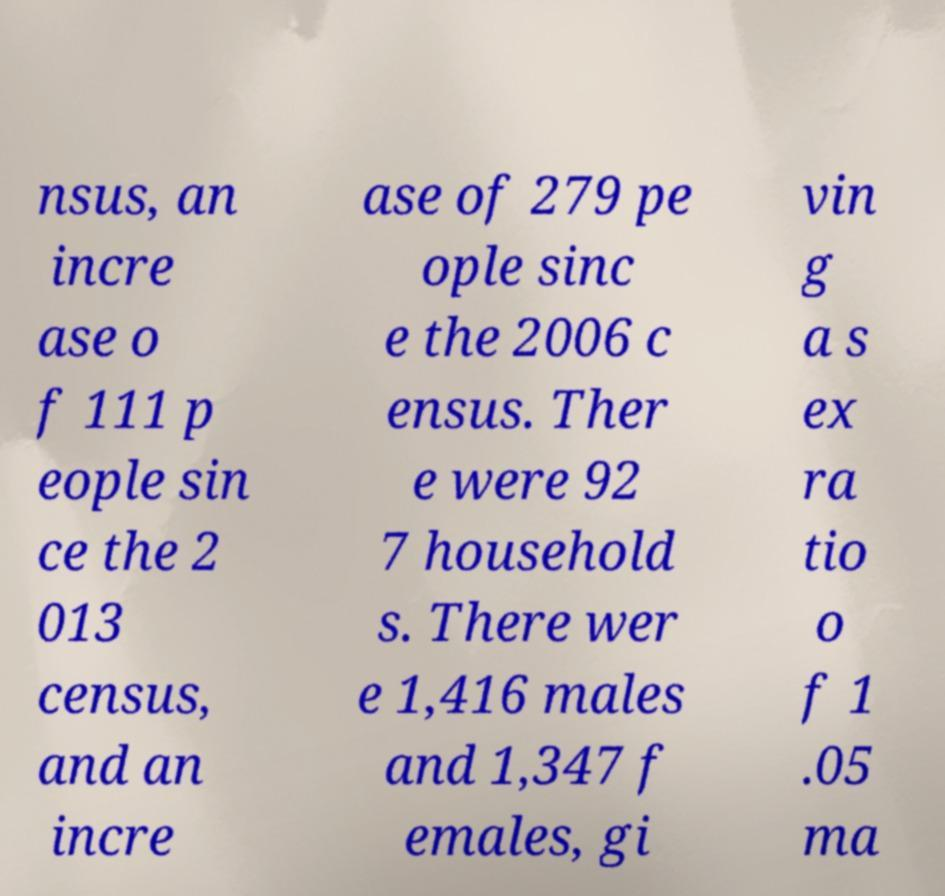Please read and relay the text visible in this image. What does it say? nsus, an incre ase o f 111 p eople sin ce the 2 013 census, and an incre ase of 279 pe ople sinc e the 2006 c ensus. Ther e were 92 7 household s. There wer e 1,416 males and 1,347 f emales, gi vin g a s ex ra tio o f 1 .05 ma 